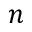<formula> <loc_0><loc_0><loc_500><loc_500>n</formula> 